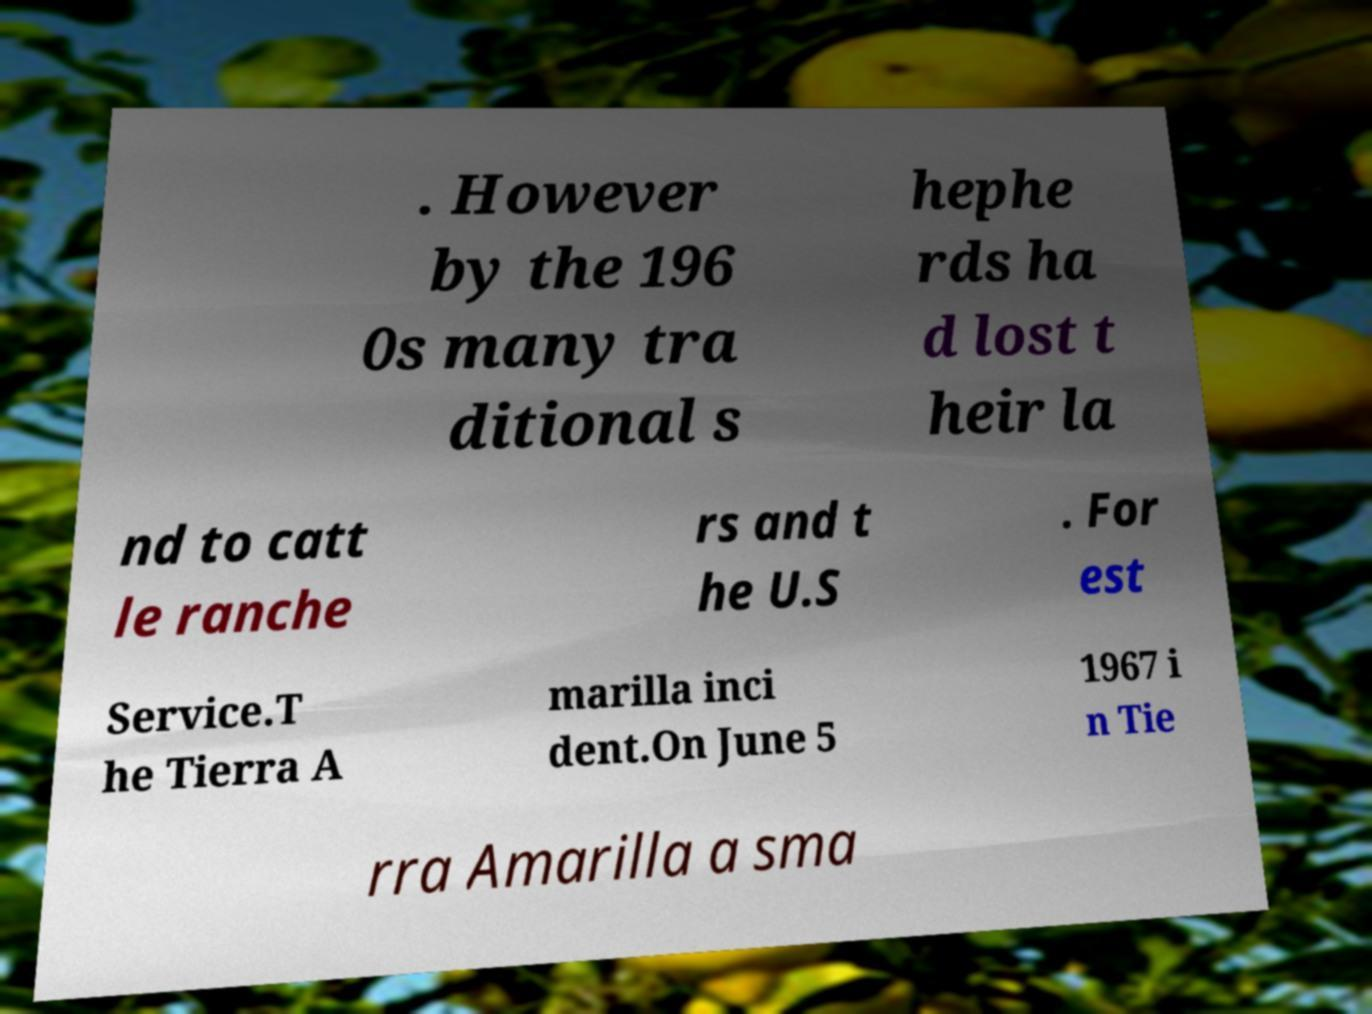Could you extract and type out the text from this image? . However by the 196 0s many tra ditional s hephe rds ha d lost t heir la nd to catt le ranche rs and t he U.S . For est Service.T he Tierra A marilla inci dent.On June 5 1967 i n Tie rra Amarilla a sma 